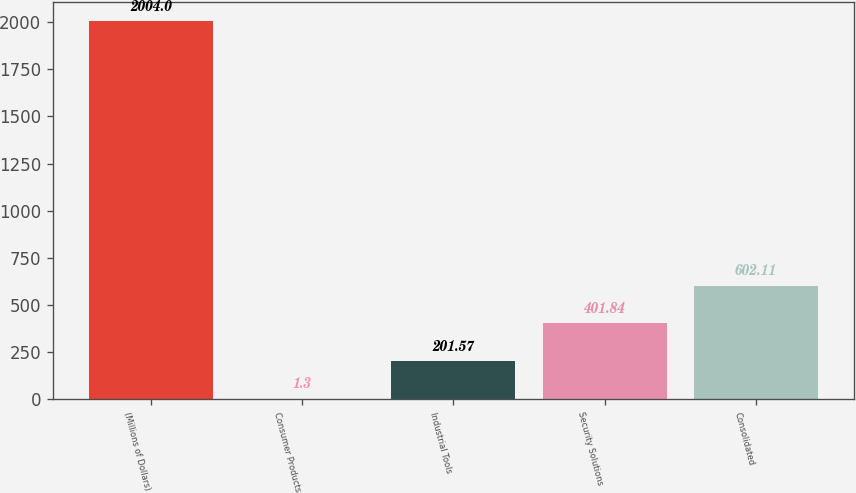Convert chart to OTSL. <chart><loc_0><loc_0><loc_500><loc_500><bar_chart><fcel>(Millions of Dollars)<fcel>Consumer Products<fcel>Industrial Tools<fcel>Security Solutions<fcel>Consolidated<nl><fcel>2004<fcel>1.3<fcel>201.57<fcel>401.84<fcel>602.11<nl></chart> 